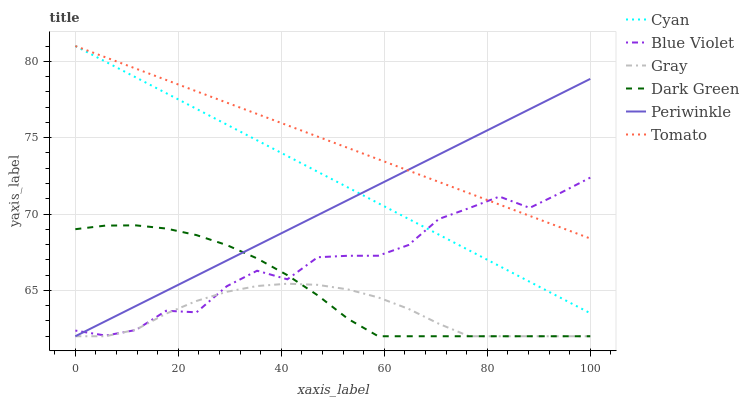Does Gray have the minimum area under the curve?
Answer yes or no. Yes. Does Tomato have the maximum area under the curve?
Answer yes or no. Yes. Does Periwinkle have the minimum area under the curve?
Answer yes or no. No. Does Periwinkle have the maximum area under the curve?
Answer yes or no. No. Is Tomato the smoothest?
Answer yes or no. Yes. Is Blue Violet the roughest?
Answer yes or no. Yes. Is Gray the smoothest?
Answer yes or no. No. Is Gray the roughest?
Answer yes or no. No. Does Gray have the lowest value?
Answer yes or no. Yes. Does Cyan have the lowest value?
Answer yes or no. No. Does Cyan have the highest value?
Answer yes or no. Yes. Does Periwinkle have the highest value?
Answer yes or no. No. Is Gray less than Tomato?
Answer yes or no. Yes. Is Tomato greater than Gray?
Answer yes or no. Yes. Does Blue Violet intersect Dark Green?
Answer yes or no. Yes. Is Blue Violet less than Dark Green?
Answer yes or no. No. Is Blue Violet greater than Dark Green?
Answer yes or no. No. Does Gray intersect Tomato?
Answer yes or no. No. 